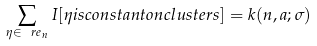Convert formula to latex. <formula><loc_0><loc_0><loc_500><loc_500>\sum _ { \eta \in \ r e _ { n } } I [ \eta i s c o n s t a n t o n c l u s t e r s ] = k ( n , a ; \sigma )</formula> 